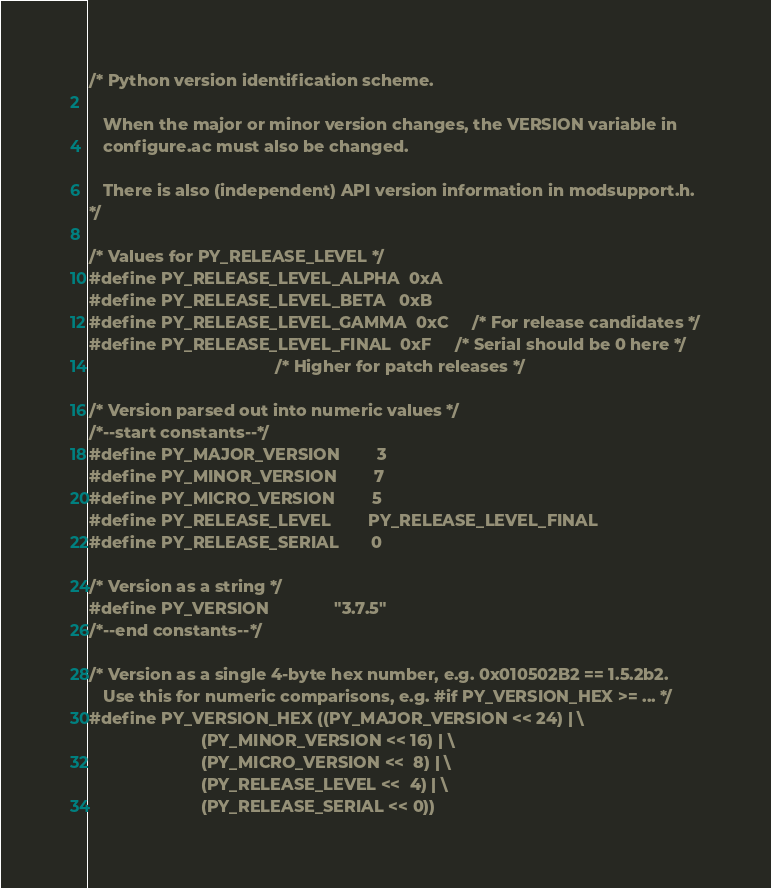<code> <loc_0><loc_0><loc_500><loc_500><_C_>
/* Python version identification scheme.

   When the major or minor version changes, the VERSION variable in
   configure.ac must also be changed.

   There is also (independent) API version information in modsupport.h.
*/

/* Values for PY_RELEASE_LEVEL */
#define PY_RELEASE_LEVEL_ALPHA  0xA
#define PY_RELEASE_LEVEL_BETA   0xB
#define PY_RELEASE_LEVEL_GAMMA  0xC     /* For release candidates */
#define PY_RELEASE_LEVEL_FINAL  0xF     /* Serial should be 0 here */
                                        /* Higher for patch releases */

/* Version parsed out into numeric values */
/*--start constants--*/
#define PY_MAJOR_VERSION        3
#define PY_MINOR_VERSION        7
#define PY_MICRO_VERSION        5
#define PY_RELEASE_LEVEL        PY_RELEASE_LEVEL_FINAL
#define PY_RELEASE_SERIAL       0

/* Version as a string */
#define PY_VERSION              "3.7.5"
/*--end constants--*/

/* Version as a single 4-byte hex number, e.g. 0x010502B2 == 1.5.2b2.
   Use this for numeric comparisons, e.g. #if PY_VERSION_HEX >= ... */
#define PY_VERSION_HEX ((PY_MAJOR_VERSION << 24) | \
                        (PY_MINOR_VERSION << 16) | \
                        (PY_MICRO_VERSION <<  8) | \
                        (PY_RELEASE_LEVEL <<  4) | \
                        (PY_RELEASE_SERIAL << 0))
</code> 